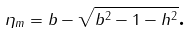Convert formula to latex. <formula><loc_0><loc_0><loc_500><loc_500>\eta _ { m } = b - \sqrt { b ^ { 2 } - 1 - h ^ { 2 } } \text {.}</formula> 